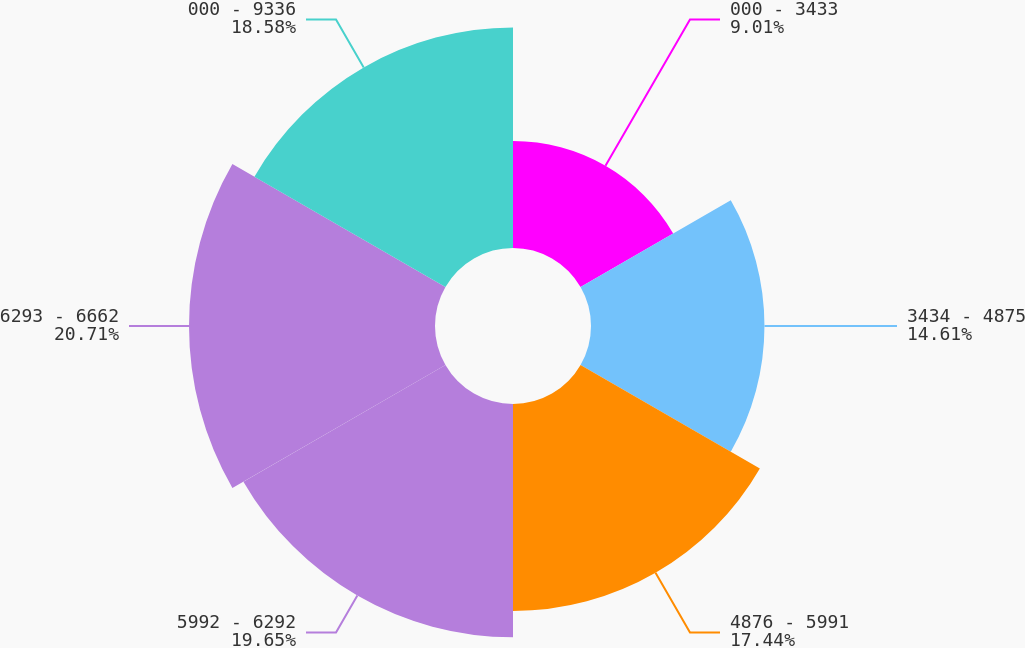Convert chart to OTSL. <chart><loc_0><loc_0><loc_500><loc_500><pie_chart><fcel>000 - 3433<fcel>3434 - 4875<fcel>4876 - 5991<fcel>5992 - 6292<fcel>6293 - 6662<fcel>000 - 9336<nl><fcel>9.01%<fcel>14.61%<fcel>17.44%<fcel>19.65%<fcel>20.72%<fcel>18.58%<nl></chart> 